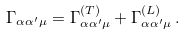Convert formula to latex. <formula><loc_0><loc_0><loc_500><loc_500>\Gamma _ { \alpha \alpha ^ { \prime } \mu } = \Gamma ^ { ( T ) } _ { \alpha \alpha ^ { \prime } \mu } + \Gamma ^ { ( L ) } _ { \alpha \alpha ^ { \prime } \mu } \, .</formula> 